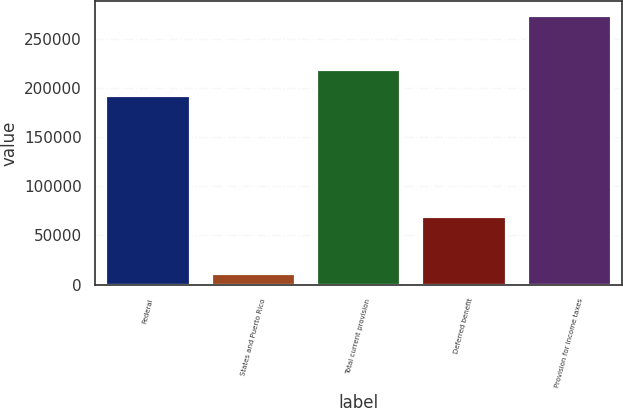Convert chart. <chart><loc_0><loc_0><loc_500><loc_500><bar_chart><fcel>Federal<fcel>States and Puerto Rico<fcel>Total current provision<fcel>Deferred benefit<fcel>Provision for income taxes<nl><fcel>192878<fcel>11722<fcel>219172<fcel>70062<fcel>274662<nl></chart> 